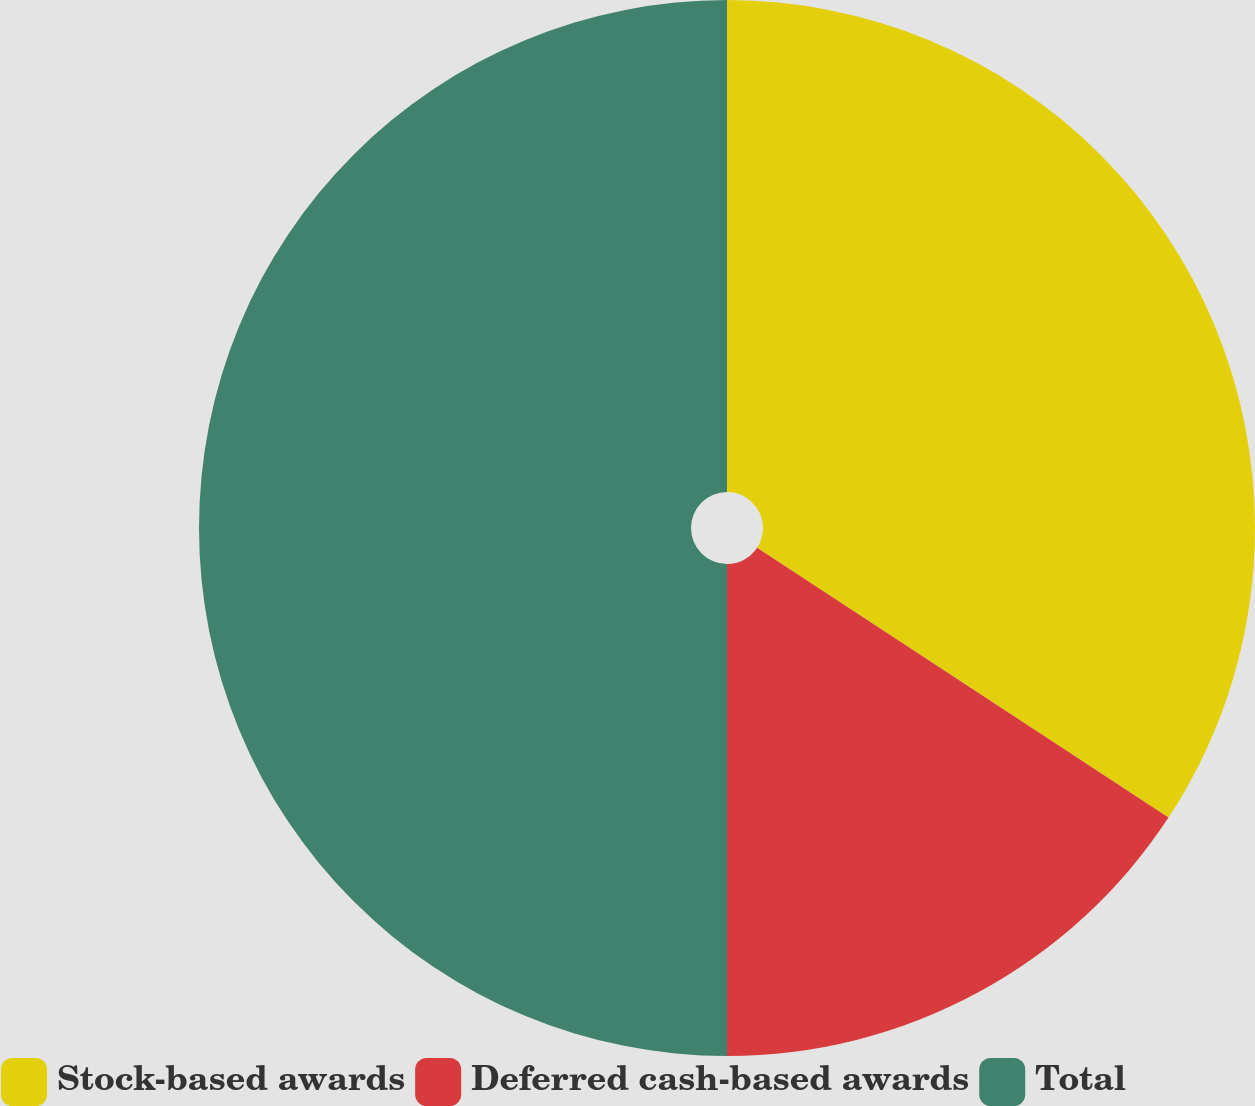Convert chart to OTSL. <chart><loc_0><loc_0><loc_500><loc_500><pie_chart><fcel>Stock-based awards<fcel>Deferred cash-based awards<fcel>Total<nl><fcel>34.24%<fcel>15.76%<fcel>50.0%<nl></chart> 